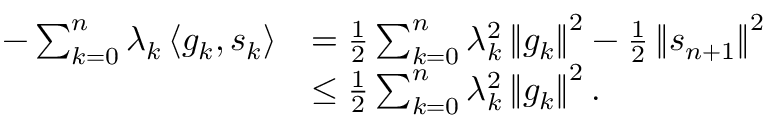<formula> <loc_0><loc_0><loc_500><loc_500>\begin{array} { r l } { - \sum _ { k = 0 } ^ { n } \lambda _ { k } \left \langle g _ { k } , s _ { k } \right \rangle } & { = \frac { 1 } { 2 } \sum _ { k = 0 } ^ { n } \lambda _ { k } ^ { 2 } \left \| g _ { k } \right \| ^ { 2 } - \frac { 1 } { 2 } \left \| s _ { n + 1 } \right \| ^ { 2 } } \\ & { \leq \frac { 1 } { 2 } \sum _ { k = 0 } ^ { n } \lambda _ { k } ^ { 2 } \left \| g _ { k } \right \| ^ { 2 } . } \end{array}</formula> 